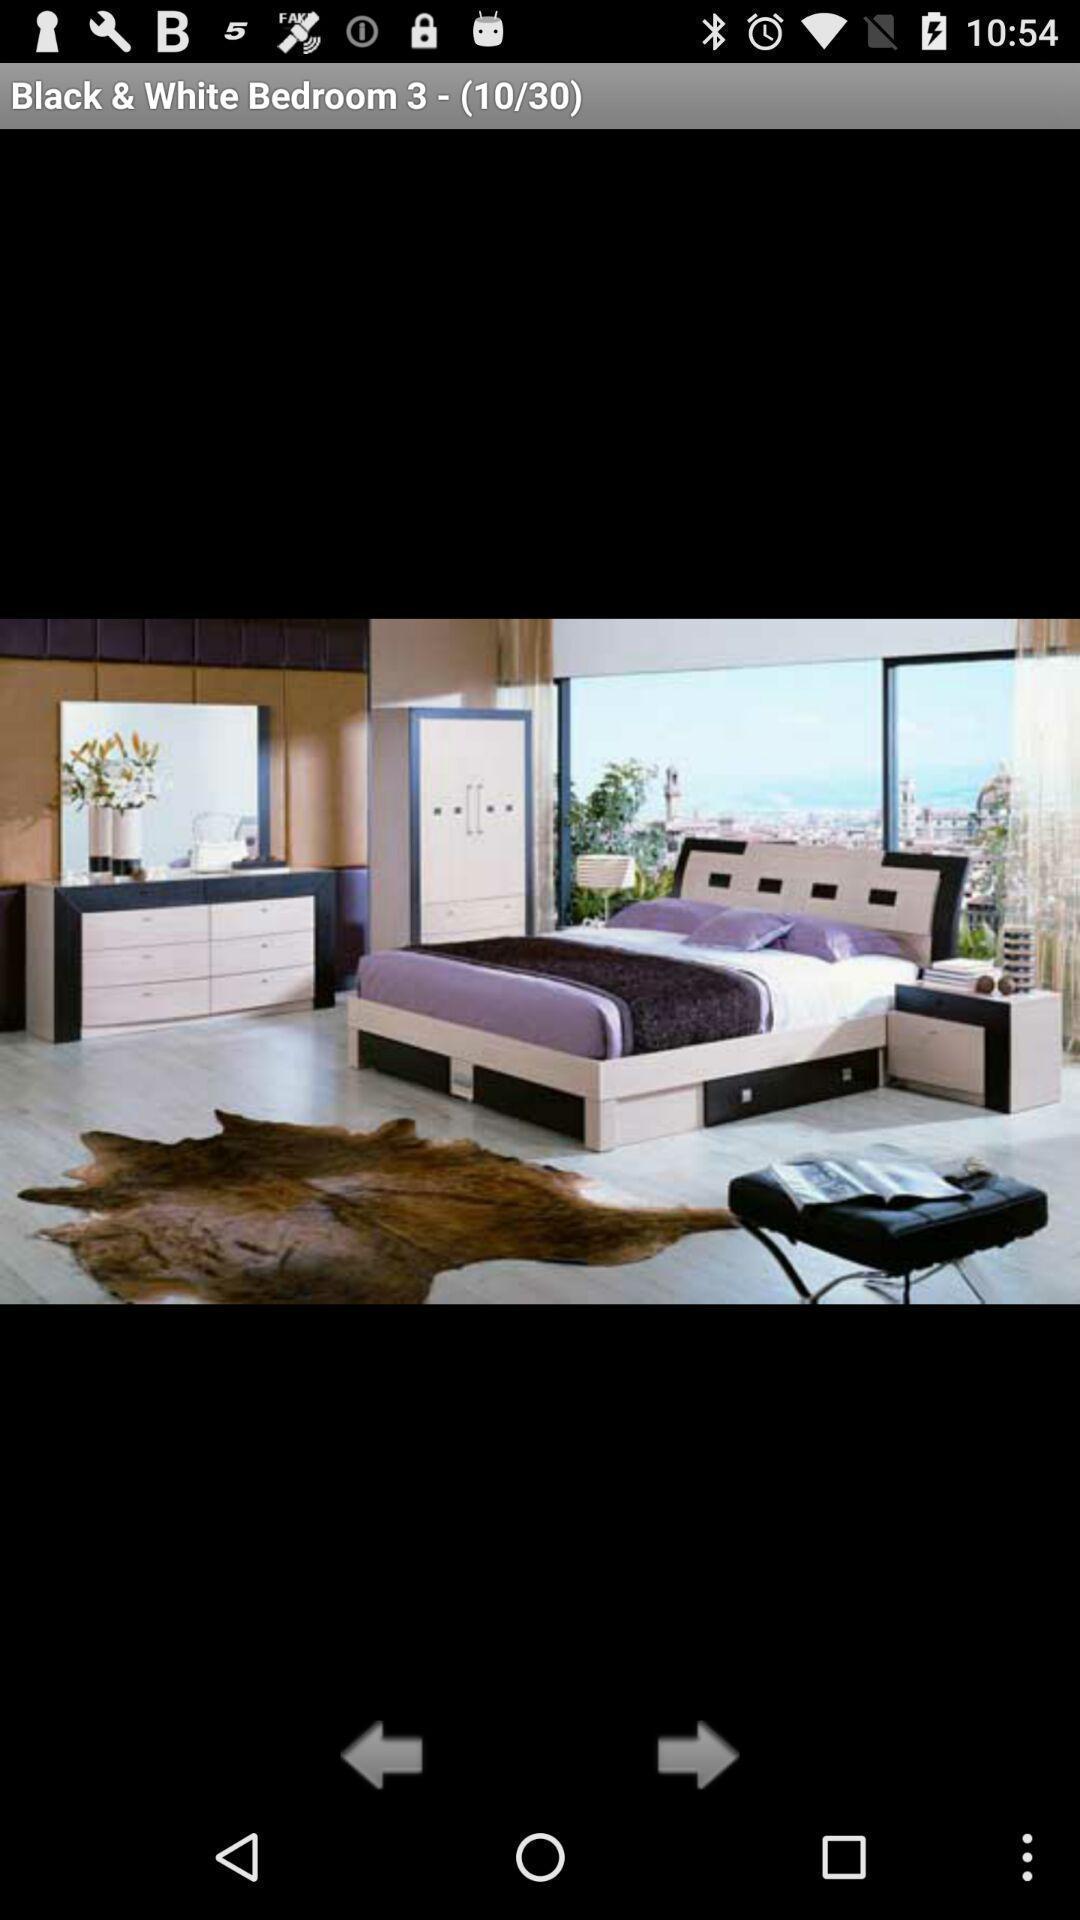Tell me about the visual elements in this screen capture. Screen show an image of room. 